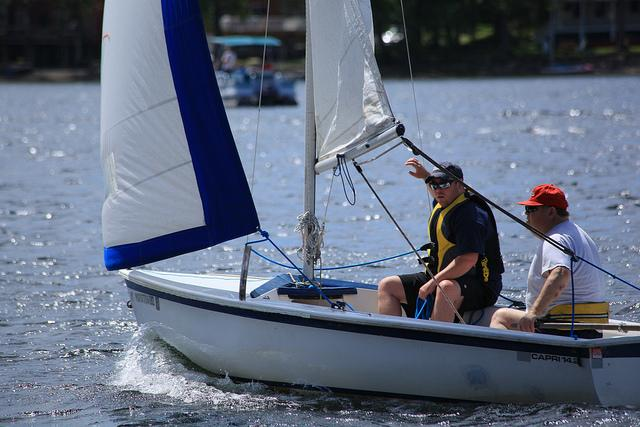What color is the border of the sail on the small boat? Please explain your reasoning. blue. The border of the sail is blue colored. 